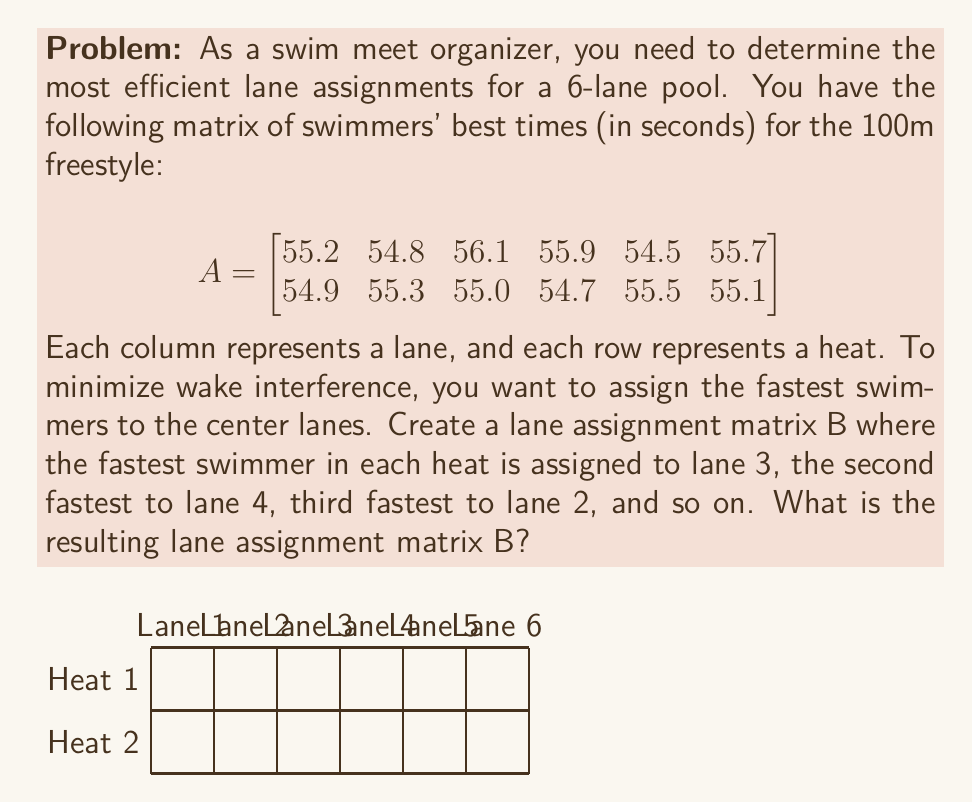Could you help me with this problem? Let's approach this step-by-step:

1) First, we need to determine the order of swimmers in each heat from fastest to slowest. We can do this by sorting each row of matrix A.

   Heat 1: 54.5, 54.8, 55.2, 55.7, 55.9, 56.1
   Heat 2: 54.7, 54.9, 55.0, 55.1, 55.3, 55.5

2) Now, we need to assign these times to lanes in the order: 3, 4, 2, 5, 1, 6. This gives us:

   Heat 1: Lane 3 (54.5), Lane 4 (54.8), Lane 2 (55.2), Lane 5 (55.7), Lane 1 (55.9), Lane 6 (56.1)
   Heat 2: Lane 3 (54.7), Lane 4 (54.9), Lane 2 (55.0), Lane 5 (55.1), Lane 1 (55.3), Lane 6 (55.5)

3) We can represent this as a matrix operation. Let's create a permutation matrix P:

   $$
   P = \begin{bmatrix}
   0 & 0 & 1 & 0 & 0 & 0 \\
   0 & 1 & 0 & 0 & 0 & 0 \\
   1 & 0 & 0 & 0 & 0 & 0 \\
   0 & 0 & 0 & 1 & 0 & 0 \\
   0 & 0 & 0 & 0 & 1 & 0 \\
   0 & 0 & 0 & 0 & 0 & 1
   \end{bmatrix}
   $$

4) The lane assignment matrix B can be obtained by multiplying A and P:

   $$
   B = A \times P
   $$

5) Performing this matrix multiplication:

   $$
   B = \begin{bmatrix}
   55.2 & 54.8 & 56.1 & 55.9 & 54.5 & 55.7 \\
   54.9 & 55.3 & 55.0 & 54.7 & 55.5 & 55.1
   \end{bmatrix} \times
   \begin{bmatrix}
   0 & 0 & 1 & 0 & 0 & 0 \\
   0 & 1 & 0 & 0 & 0 & 0 \\
   1 & 0 & 0 & 0 & 0 & 0 \\
   0 & 0 & 0 & 1 & 0 & 0 \\
   0 & 0 & 0 & 0 & 1 & 0 \\
   0 & 0 & 0 & 0 & 0 & 1
   \end{bmatrix}
   $$

   $$
   = \begin{bmatrix}
   55.9 & 55.2 & 54.5 & 54.8 & 55.7 & 56.1 \\
   55.3 & 55.0 & 54.7 & 54.9 & 55.1 & 55.5
   \end{bmatrix}
   $$

This resulting matrix B represents the optimal lane assignments for minimizing wake interference.
Answer: $$B = \begin{bmatrix}
55.9 & 55.2 & 54.5 & 54.8 & 55.7 & 56.1 \\
55.3 & 55.0 & 54.7 & 54.9 & 55.1 & 55.5
\end{bmatrix}$$ 